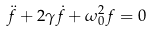Convert formula to latex. <formula><loc_0><loc_0><loc_500><loc_500>\ddot { f } + 2 \gamma \dot { f } + \omega _ { 0 } ^ { 2 } f = 0</formula> 